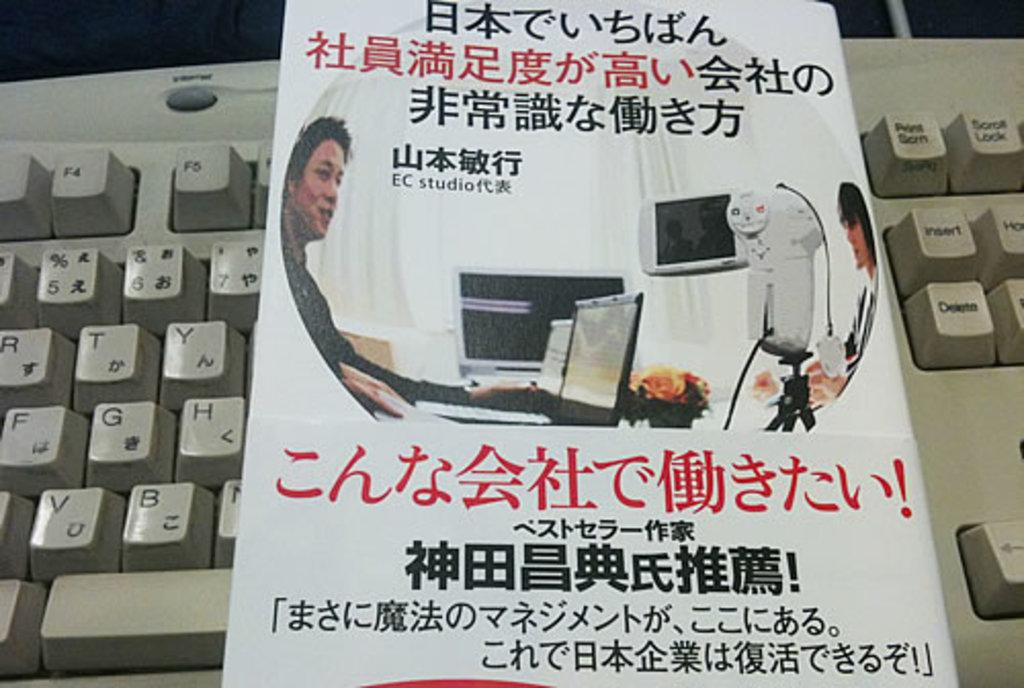What color is the keyboard in the image? The keyboard in the image is white-colored. What is placed on the keyboard? There is a white-colored object on the keyboard. Can you describe what is written on the object? Unfortunately, the specific text on the object cannot be determined from the image. What type of shoes is the person wearing in the image? There is no person or shoes present in the image; it only features a white-colored keyboard with a white-colored object on it. 